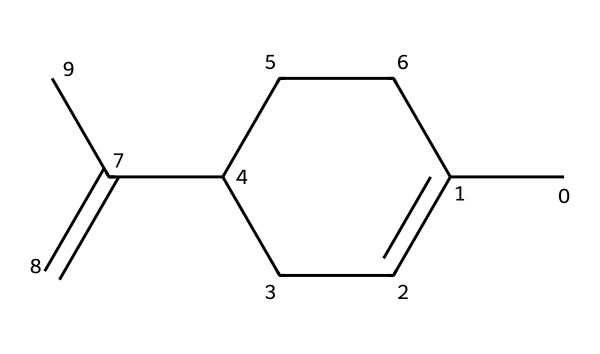What is the name of this hydrocarbon? The SMILES representation provided is that of limonene, which is commonly known as a fragrant hydrocarbon used in various products.
Answer: limonene How many carbon atoms are in limonene? By analyzing the SMILES, we can see that there are a total of 10 carbon atoms represented in the structure.
Answer: 10 How many double bonds are present in the structure of limonene? The SMILES indicates one double bond between carbon atoms, as denoted by the '=' sign in the structure.
Answer: 1 What is the degree of unsaturation in limonene? The degree of unsaturation can be calculated based on the number of rings and double bonds. In this case, limonene has one double bond and one ring, leading to a degree of unsaturation of 2.
Answer: 2 Is limonene a cyclic hydrocarbon? The structure of limonene contains a ring (indicated by the notation 'C1...C1'), confirming that it is a cyclic hydrocarbon.
Answer: Yes Which functional group is primarily responsible for the characteristic scent of limonene? The unsaturation (double bond) in the structure contributes to the reactivity and scent profile of limonene, distinguishing it as a fragrant compound in the hydrocarbon category.
Answer: alkene 